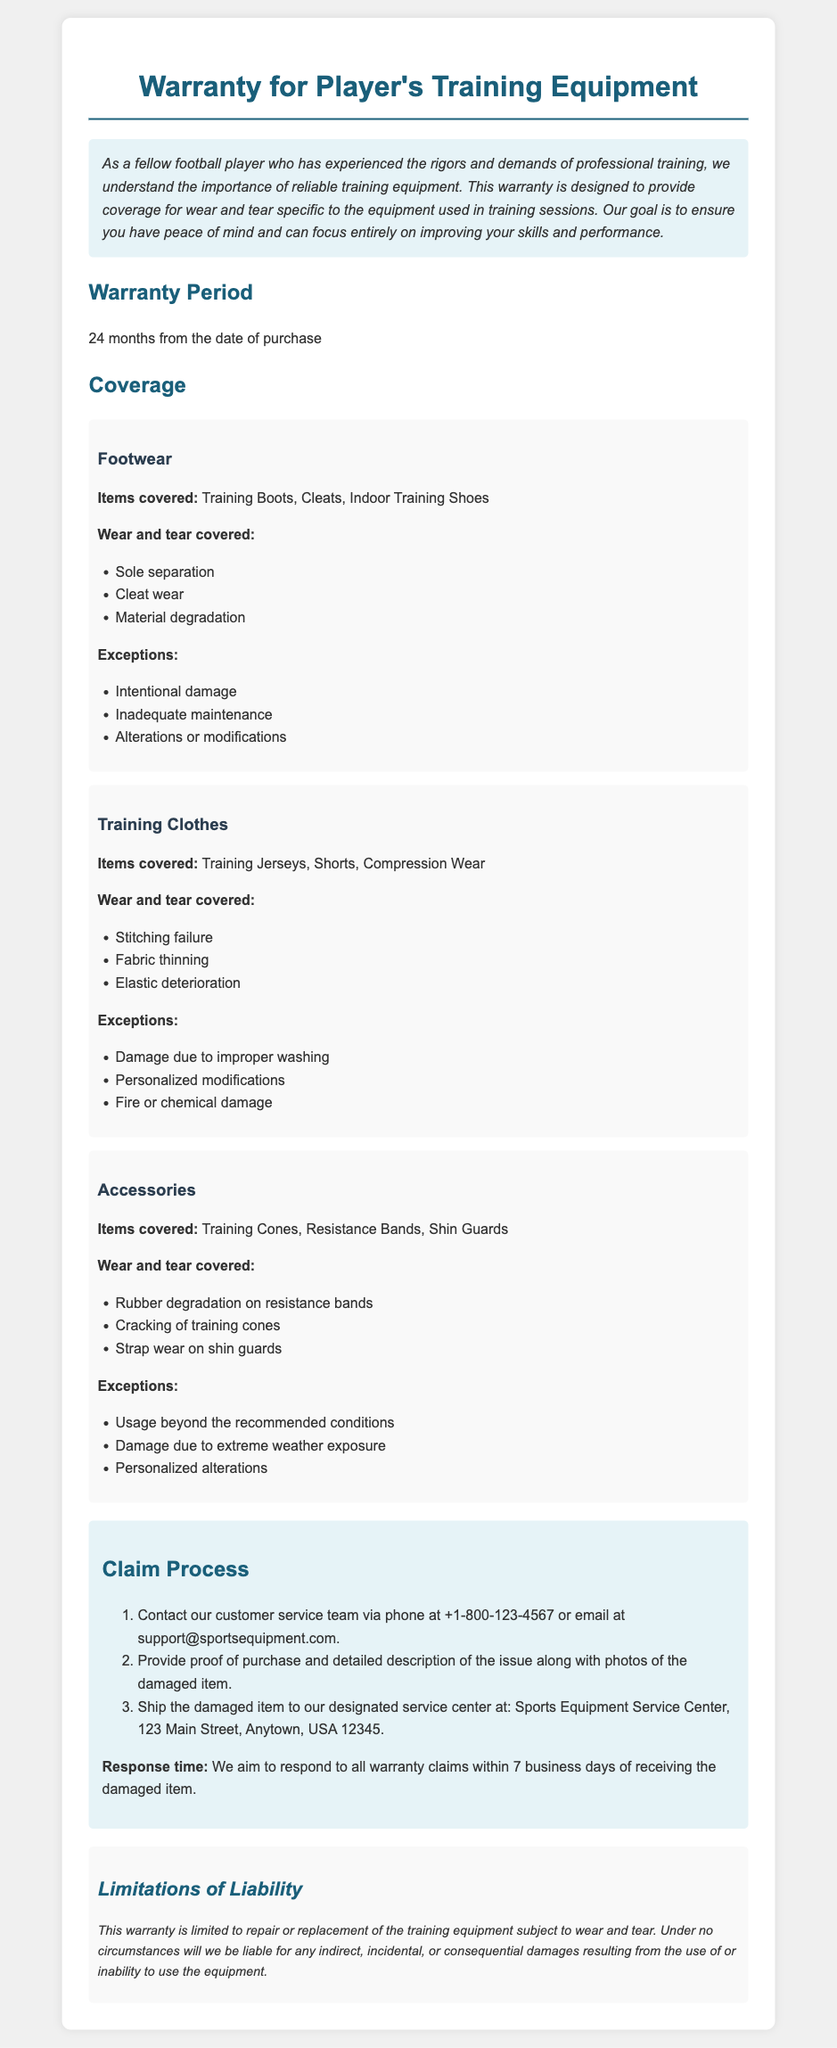What is the warranty period? The warranty period is defined in the document under "Warranty Period" as 24 months from the date of purchase.
Answer: 24 months What items are covered under Footwear? The items covered under Footwear are listed in the document as Training Boots, Cleats, Indoor Training Shoes.
Answer: Training Boots, Cleats, Indoor Training Shoes What is a reason for denial of coverage for Training Clothes? The document states that damage due to improper washing is among the exceptions for coverage denial under Training Clothes.
Answer: Damage due to improper washing What is the response time for warranty claims? The response time for warranty claims is specified in the claim process section and is stated as within 7 business days of receiving the damaged item.
Answer: 7 business days What type of damages are explicitly excluded in the limitations of liability? The limitations of liability section states that the warranty excludes direct, incidental, or consequential damages from the use of the equipment.
Answer: Indirect, incidental, or consequential damages Which accessory is covered under the warranty? The document mentions Training Cones, Resistance Bands, and Shin Guards under Accessories as items covered.
Answer: Training Cones, Resistance Bands, Shin Guards What needs to be provided when filing a claim? According to the claim process, proof of purchase and detailed description of the issue along with photos of the damaged item need to be provided.
Answer: Proof of purchase and detailed description of the issue Which wear and tear on footwear is covered? The document lists sole separation, cleat wear, and material degradation as covered wear and tear for footwear.
Answer: Sole separation, cleat wear, material degradation What is the contact method for warranty claims? The document specifies that claims can be made via phone or email, providing the contact information in the claim process.
Answer: Phone or email 